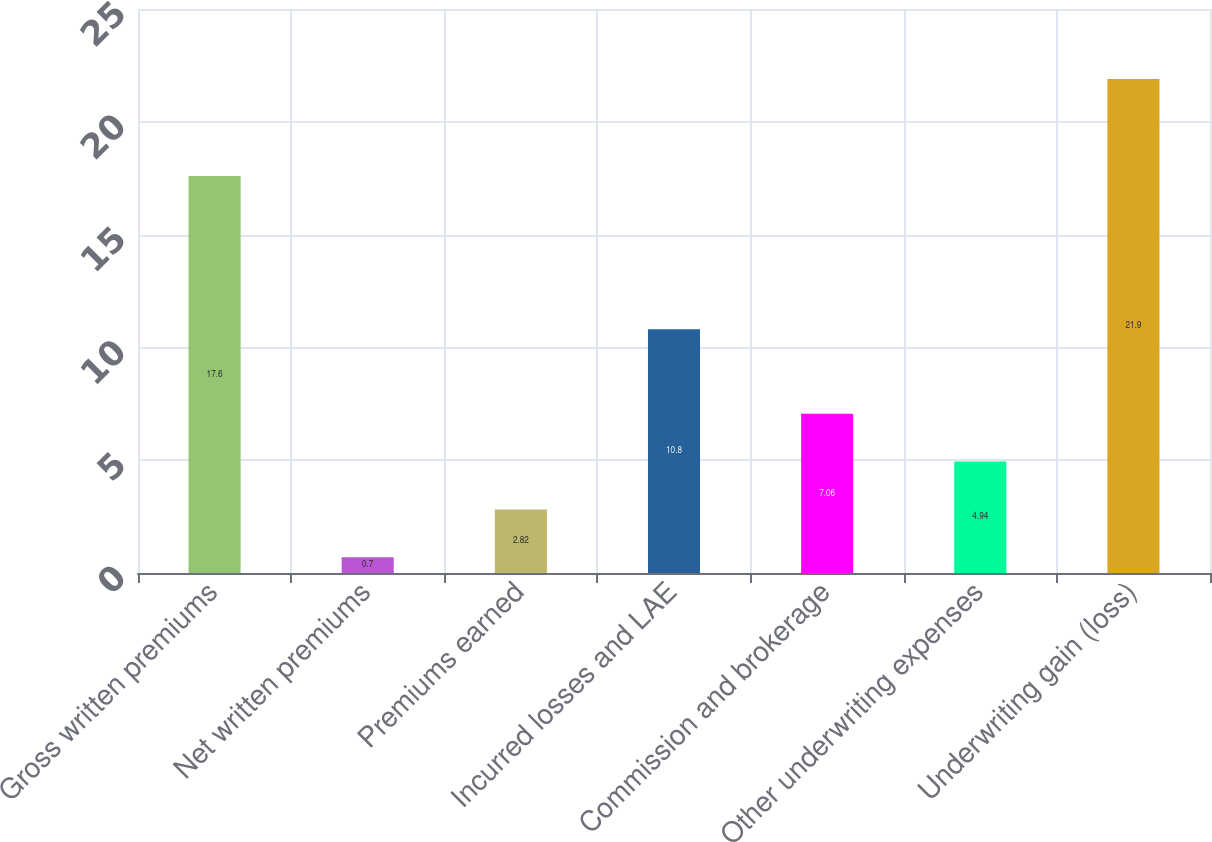Convert chart. <chart><loc_0><loc_0><loc_500><loc_500><bar_chart><fcel>Gross written premiums<fcel>Net written premiums<fcel>Premiums earned<fcel>Incurred losses and LAE<fcel>Commission and brokerage<fcel>Other underwriting expenses<fcel>Underwriting gain (loss)<nl><fcel>17.6<fcel>0.7<fcel>2.82<fcel>10.8<fcel>7.06<fcel>4.94<fcel>21.9<nl></chart> 